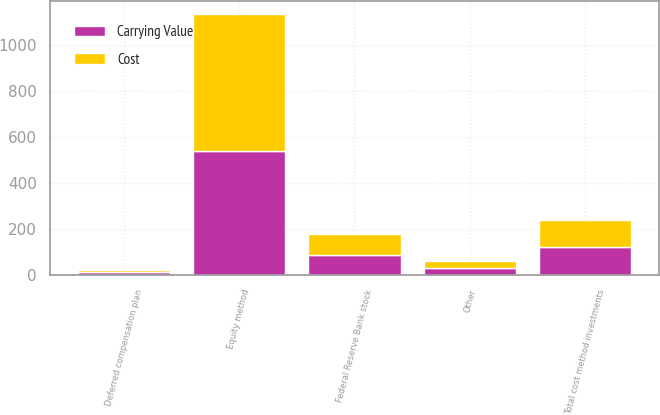Convert chart. <chart><loc_0><loc_0><loc_500><loc_500><stacked_bar_chart><ecel><fcel>Equity method<fcel>Deferred compensation plan<fcel>Federal Reserve Bank stock<fcel>Other<fcel>Total cost method investments<nl><fcel>Carrying Value<fcel>541<fcel>15<fcel>89<fcel>31<fcel>120<nl><fcel>Cost<fcel>595<fcel>9<fcel>89<fcel>31<fcel>120<nl></chart> 